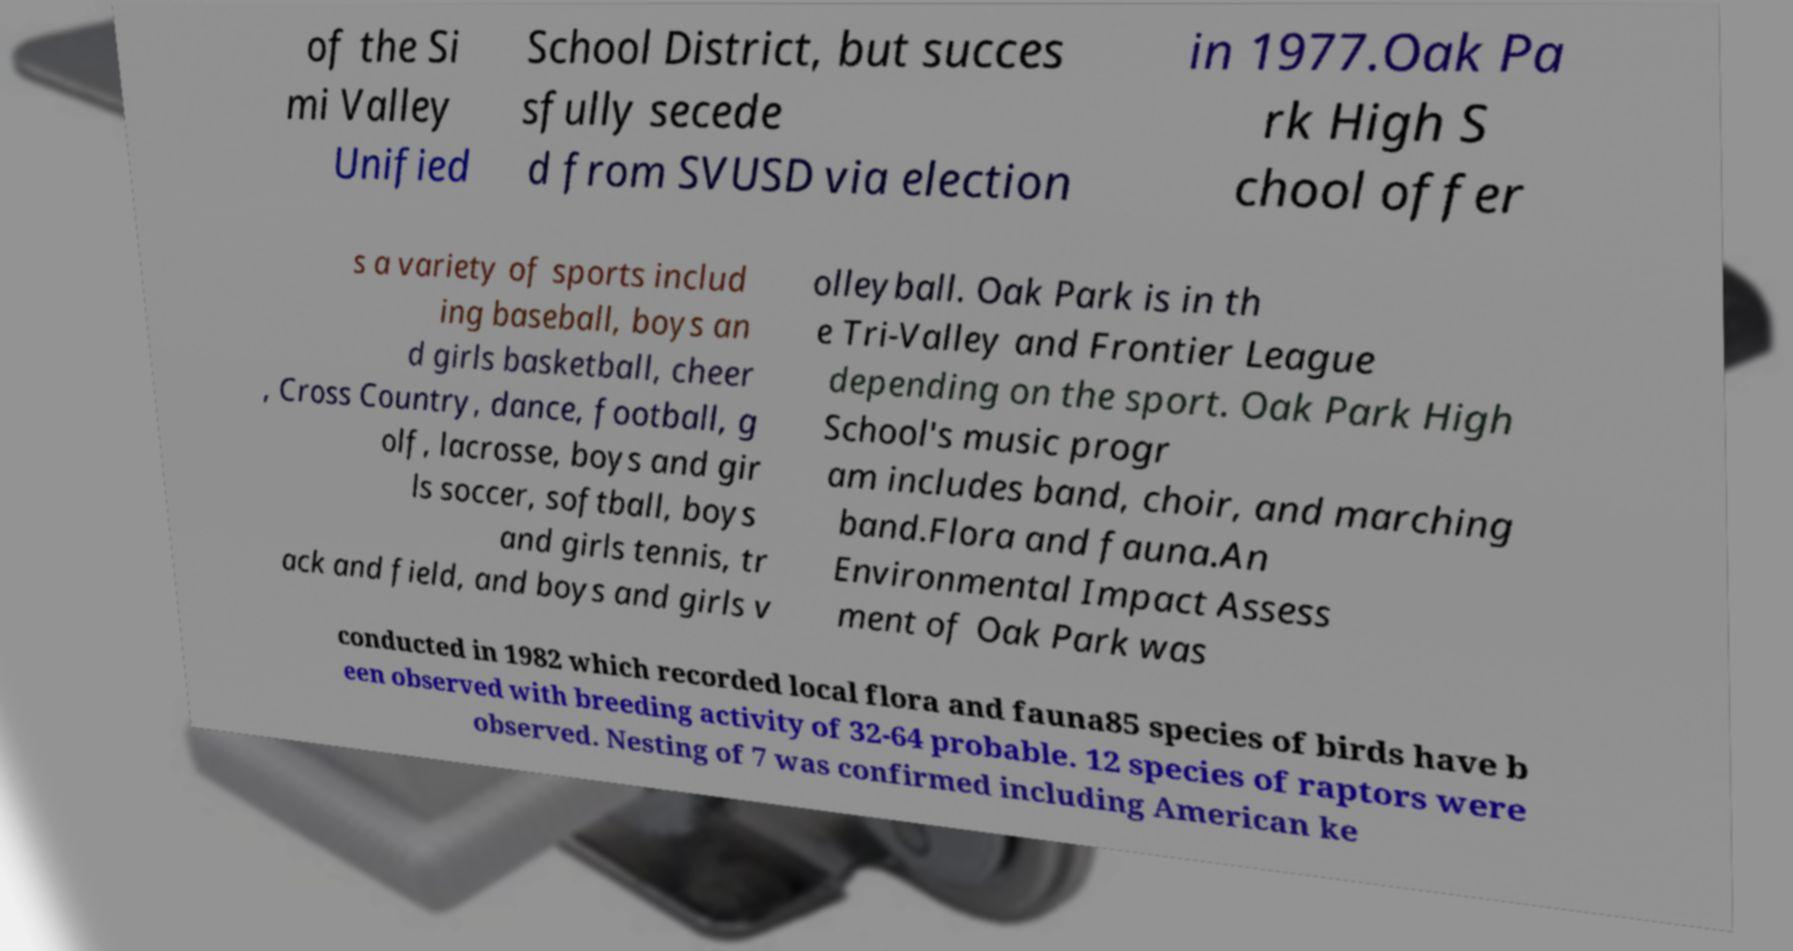For documentation purposes, I need the text within this image transcribed. Could you provide that? of the Si mi Valley Unified School District, but succes sfully secede d from SVUSD via election in 1977.Oak Pa rk High S chool offer s a variety of sports includ ing baseball, boys an d girls basketball, cheer , Cross Country, dance, football, g olf, lacrosse, boys and gir ls soccer, softball, boys and girls tennis, tr ack and field, and boys and girls v olleyball. Oak Park is in th e Tri-Valley and Frontier League depending on the sport. Oak Park High School's music progr am includes band, choir, and marching band.Flora and fauna.An Environmental Impact Assess ment of Oak Park was conducted in 1982 which recorded local flora and fauna85 species of birds have b een observed with breeding activity of 32-64 probable. 12 species of raptors were observed. Nesting of 7 was confirmed including American ke 